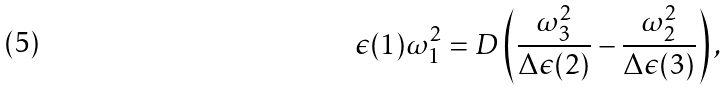<formula> <loc_0><loc_0><loc_500><loc_500>\epsilon ( 1 ) \omega _ { 1 } ^ { 2 } = D \left ( \frac { \omega _ { 3 } ^ { 2 } } { \Delta \epsilon ( 2 ) } - \frac { \omega _ { 2 } ^ { 2 } } { \Delta \epsilon ( 3 ) } \right ) ,</formula> 